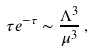<formula> <loc_0><loc_0><loc_500><loc_500>\tau e ^ { - \tau } \sim \frac { \Lambda ^ { 3 } } { \mu ^ { 3 } } \, ,</formula> 